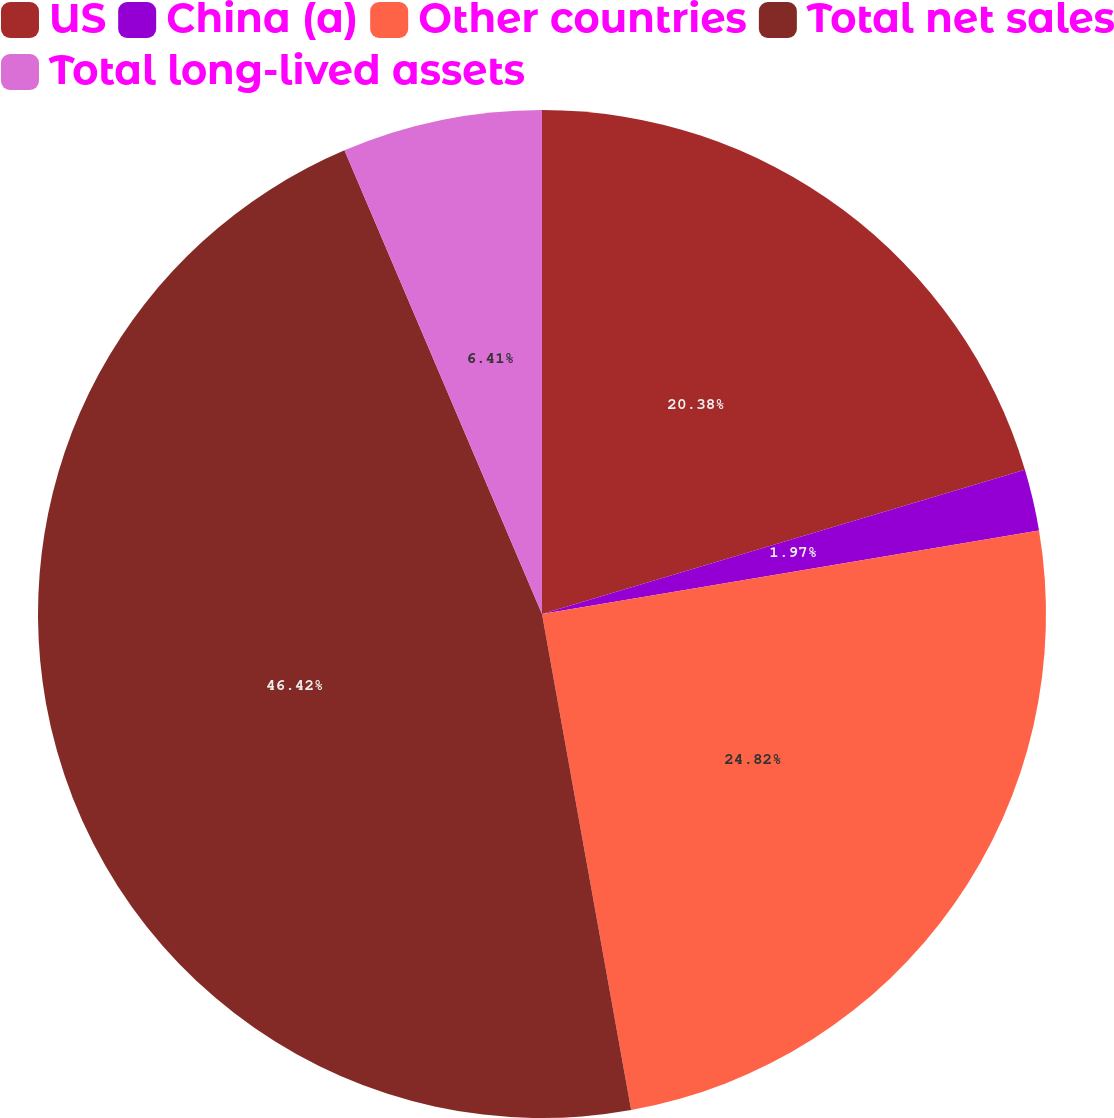Convert chart. <chart><loc_0><loc_0><loc_500><loc_500><pie_chart><fcel>US<fcel>China (a)<fcel>Other countries<fcel>Total net sales<fcel>Total long-lived assets<nl><fcel>20.38%<fcel>1.97%<fcel>24.82%<fcel>46.42%<fcel>6.41%<nl></chart> 